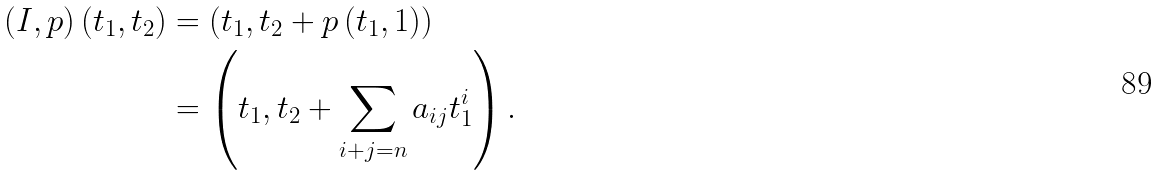Convert formula to latex. <formula><loc_0><loc_0><loc_500><loc_500>( I , p ) \left ( t _ { 1 } , t _ { 2 } \right ) & = \left ( t _ { 1 } , t _ { 2 } + p \left ( t _ { 1 } , 1 \right ) \right ) \\ & = \left ( t _ { 1 } , t _ { 2 } + \sum _ { i + j = n } a _ { i j } t _ { 1 } ^ { i } \right ) .</formula> 